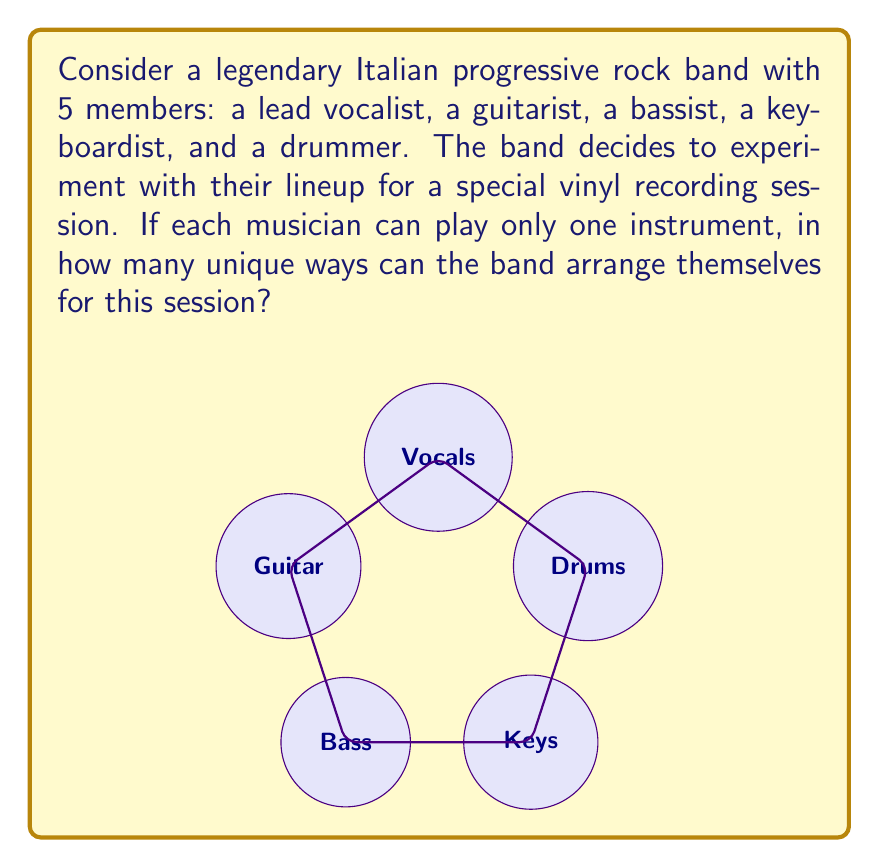Give your solution to this math problem. Let's approach this step-by-step:

1) This is a permutation problem. We need to calculate the number of ways to arrange 5 distinct objects (the musicians) in 5 positions.

2) The formula for permutations of n distinct objects is:

   $$P(n) = n!$$

   Where $n!$ represents the factorial of n.

3) In this case, $n = 5$, so we need to calculate $5!$

4) Let's expand this:
   
   $$5! = 5 \times 4 \times 3 \times 2 \times 1$$

5) Calculating this:
   
   $$5! = 120$$

6) Therefore, there are 120 unique ways the band can arrange themselves.

This means that for each arrangement, each musician is playing a different instrument than they usually do (except for one musician who might end up in their usual position).
Answer: $120$ 